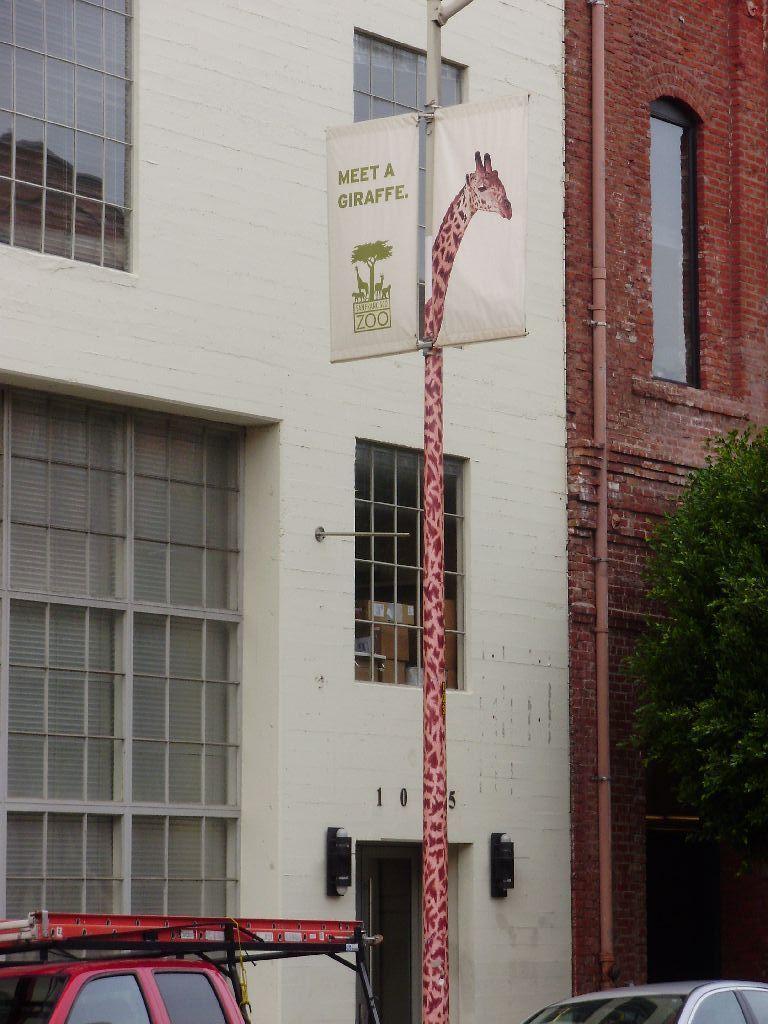Could you give a brief overview of what you see in this image? This image is clicked on the road. In the front, there are buildings along with windows. In the middle, we can see a pole on which there is a small banner. On the right, there is a tree. At the bottom, there are two cars. 